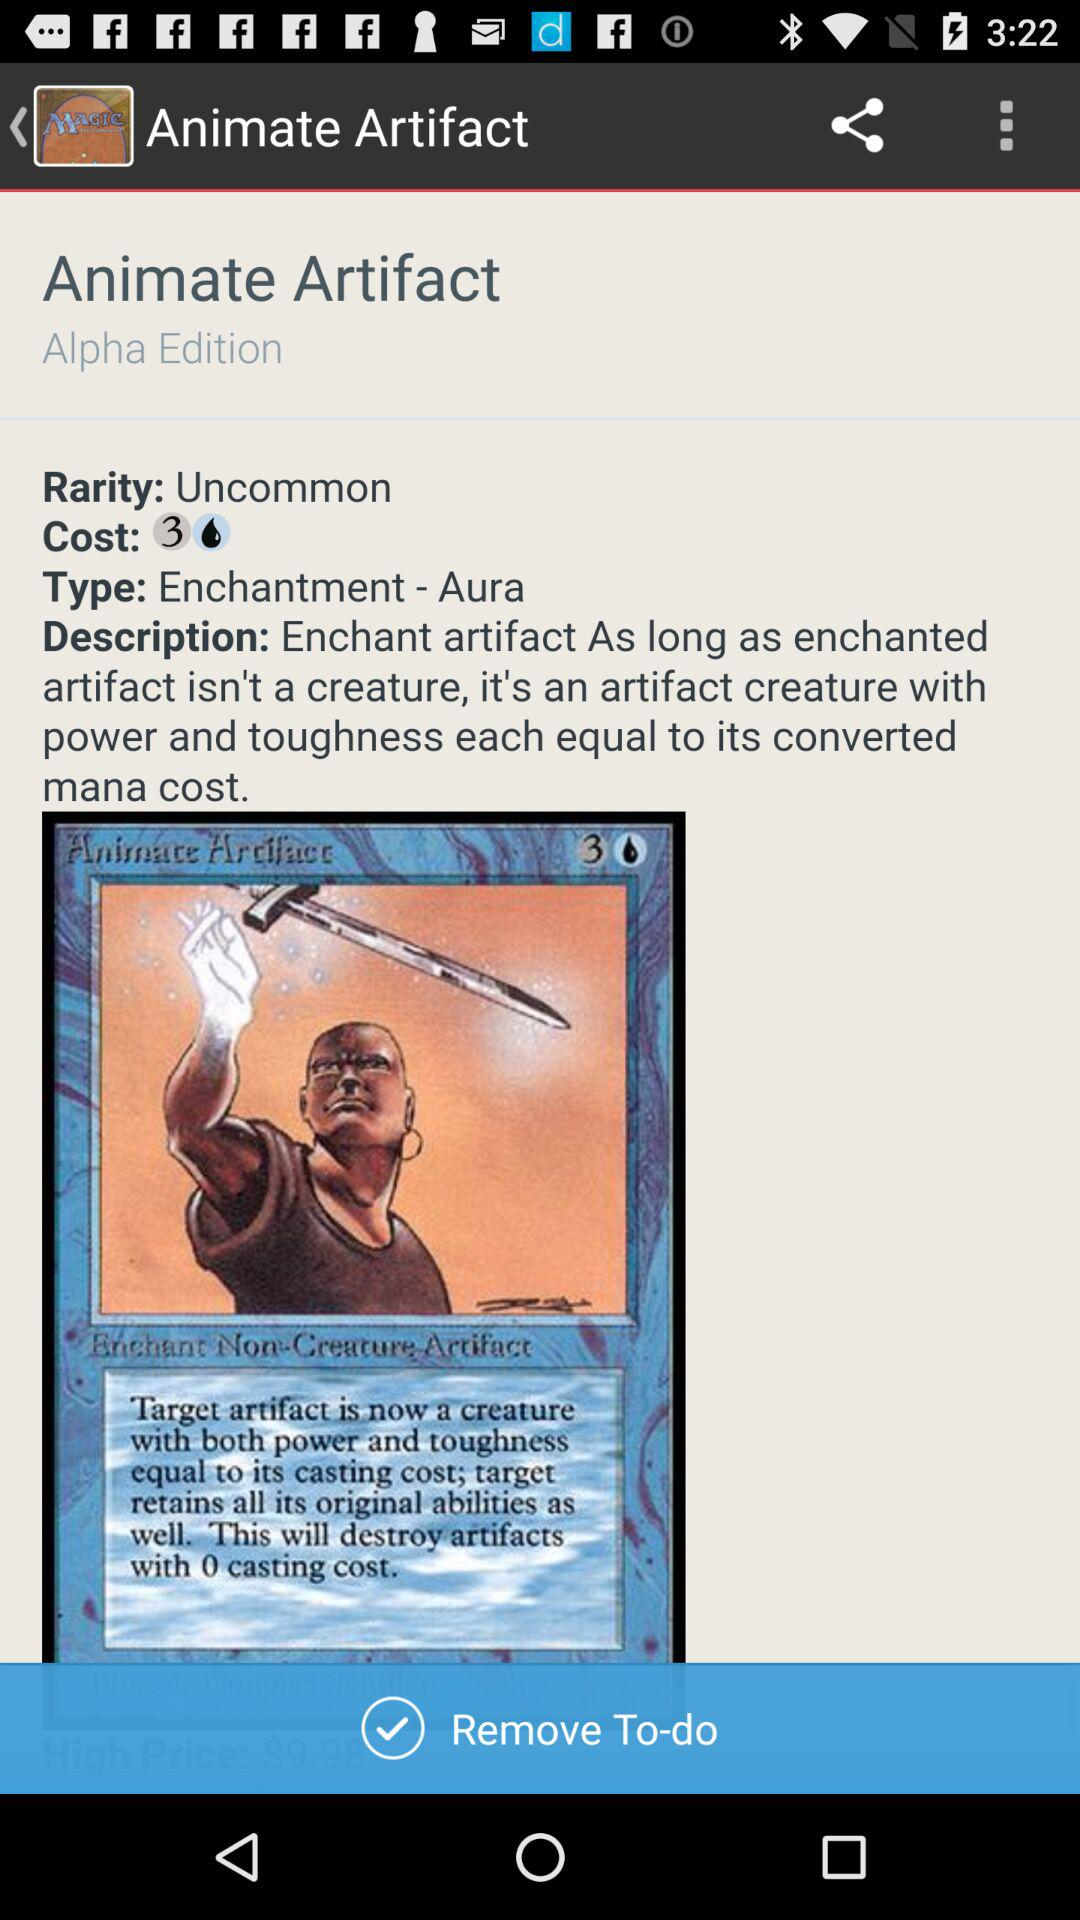Who created this card?
When the provided information is insufficient, respond with <no answer>. <no answer> 